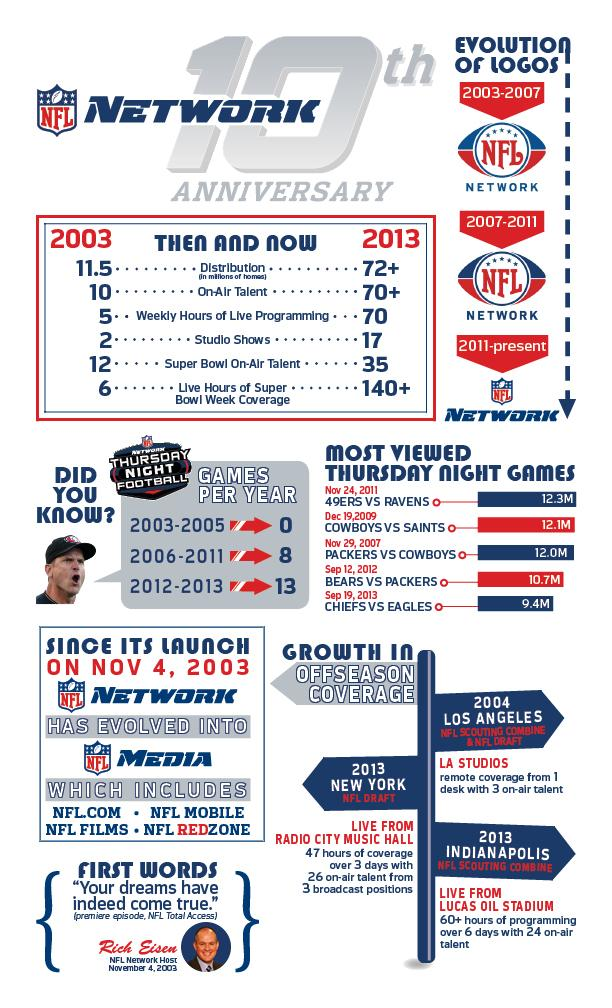Specify some key components in this picture. In 2009, the Thursday night game with the second highest number of views was held. 